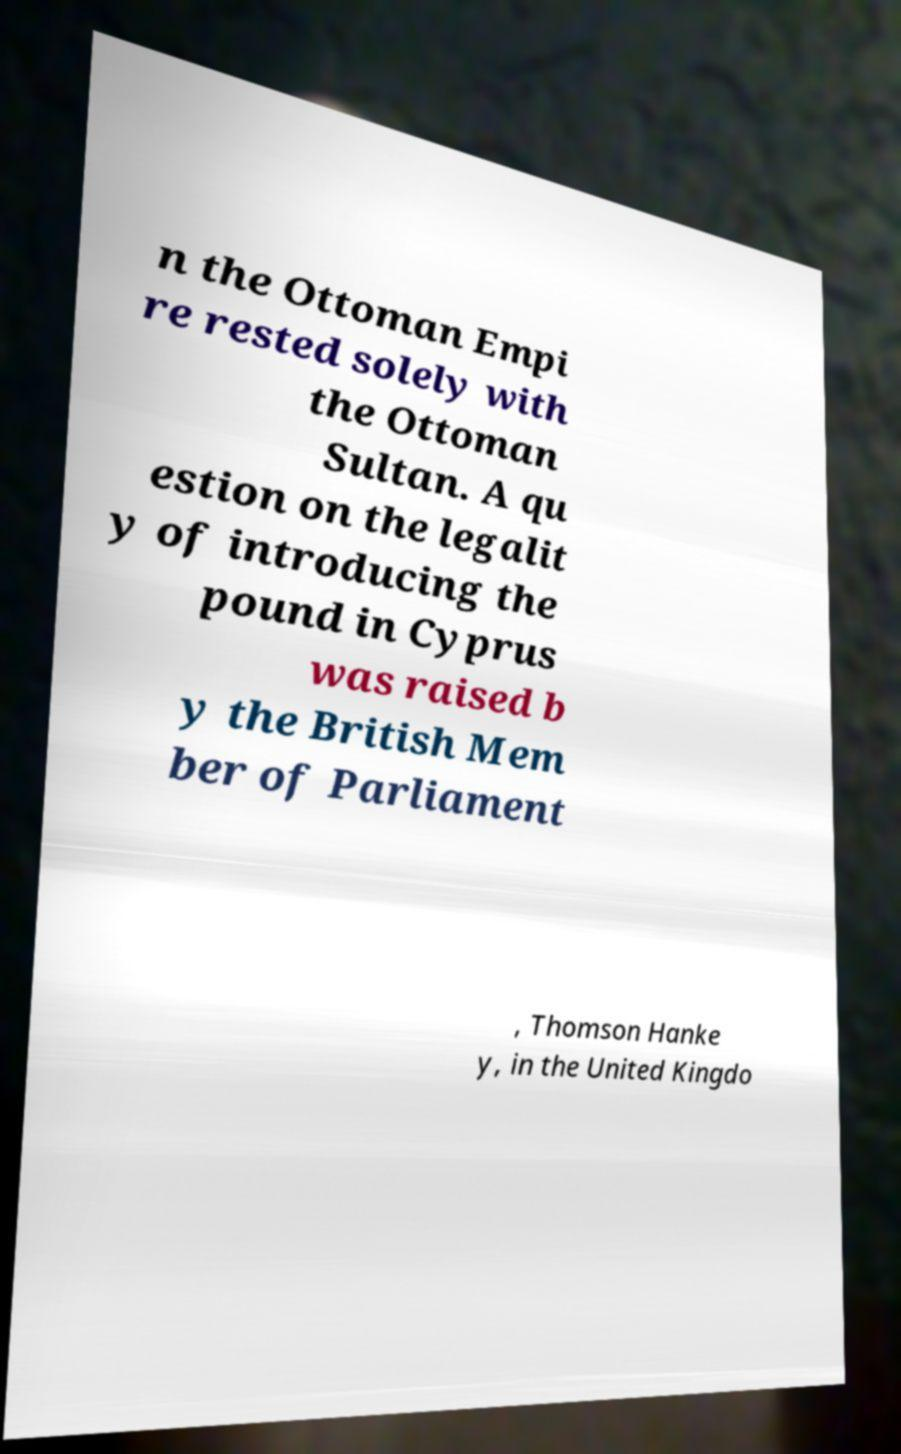Could you assist in decoding the text presented in this image and type it out clearly? n the Ottoman Empi re rested solely with the Ottoman Sultan. A qu estion on the legalit y of introducing the pound in Cyprus was raised b y the British Mem ber of Parliament , Thomson Hanke y, in the United Kingdo 